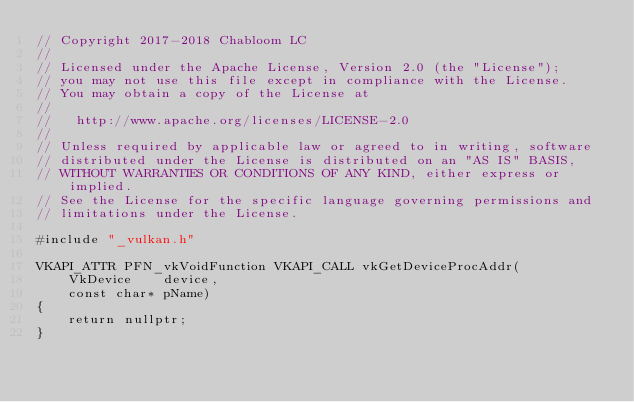Convert code to text. <code><loc_0><loc_0><loc_500><loc_500><_ObjectiveC_>// Copyright 2017-2018 Chabloom LC
//
// Licensed under the Apache License, Version 2.0 (the "License");
// you may not use this file except in compliance with the License.
// You may obtain a copy of the License at
//
//   http://www.apache.org/licenses/LICENSE-2.0
//
// Unless required by applicable law or agreed to in writing, software
// distributed under the License is distributed on an "AS IS" BASIS,
// WITHOUT WARRANTIES OR CONDITIONS OF ANY KIND, either express or implied.
// See the License for the specific language governing permissions and
// limitations under the License.

#include "_vulkan.h"

VKAPI_ATTR PFN_vkVoidFunction VKAPI_CALL vkGetDeviceProcAddr(
    VkDevice    device,
    const char* pName)
{
    return nullptr;
}
</code> 